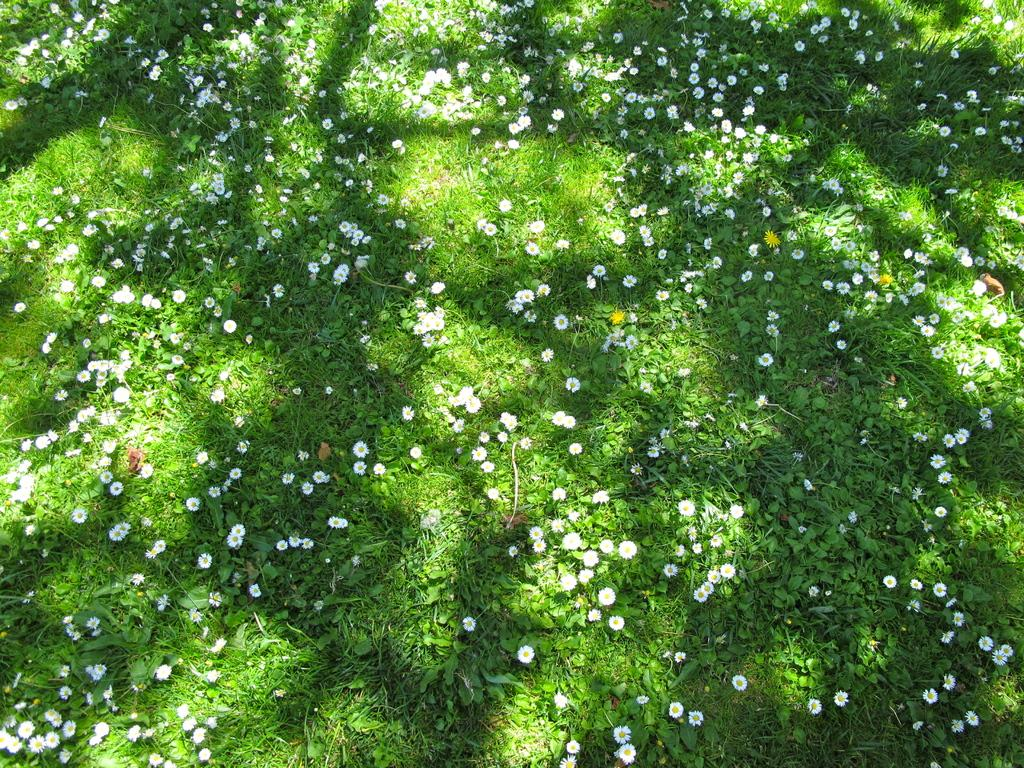What type of vegetation covers the ground in the image? The ground is covered with grass in the image. Are there any other plants visible besides the grass? Yes, there are flowers visible in the image. What advice does the mother give to the person in the image? There is no mother or person present in the image, so it is not possible to answer that question. 